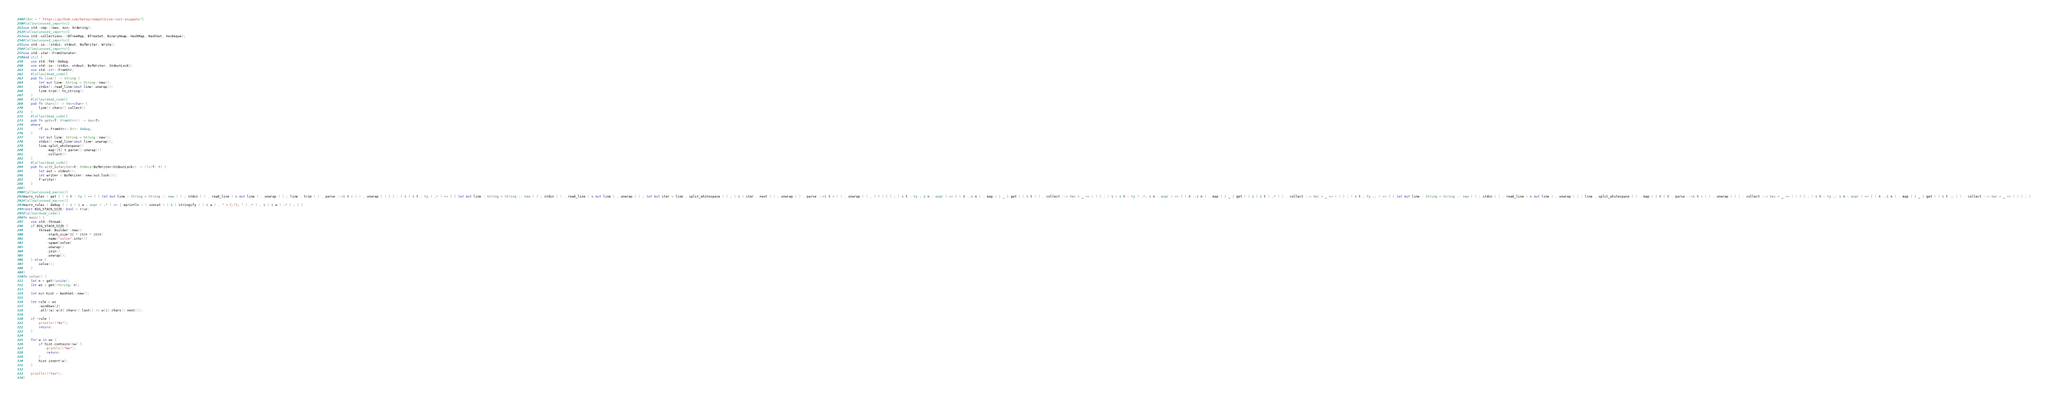Convert code to text. <code><loc_0><loc_0><loc_500><loc_500><_Rust_>#[doc = " https://github.com/hatoo/competitive-rust-snippets"]
#[allow(unused_imports)]
use std::cmp::{max, min, Ordering};
#[allow(unused_imports)]
use std::collections::{BTreeMap, BTreeSet, BinaryHeap, HashMap, HashSet, VecDeque};
#[allow(unused_imports)]
use std::io::{stdin, stdout, BufWriter, Write};
#[allow(unused_imports)]
use std::iter::FromIterator;
mod util {
    use std::fmt::Debug;
    use std::io::{stdin, stdout, BufWriter, StdoutLock};
    use std::str::FromStr;
    #[allow(dead_code)]
    pub fn line() -> String {
        let mut line: String = String::new();
        stdin().read_line(&mut line).unwrap();
        line.trim().to_string()
    }
    #[allow(dead_code)]
    pub fn chars() -> Vec<char> {
        line().chars().collect()
    }
    #[allow(dead_code)]
    pub fn gets<T: FromStr>() -> Vec<T>
    where
        <T as FromStr>::Err: Debug,
    {
        let mut line: String = String::new();
        stdin().read_line(&mut line).unwrap();
        line.split_whitespace()
            .map(|t| t.parse().unwrap())
            .collect()
    }
    #[allow(dead_code)]
    pub fn with_bufwriter<F: FnOnce(BufWriter<StdoutLock>) -> ()>(f: F) {
        let out = stdout();
        let writer = BufWriter::new(out.lock());
        f(writer)
    }
}
#[allow(unused_macros)]
macro_rules ! get { ( $ t : ty ) => { { let mut line : String = String :: new ( ) ; stdin ( ) . read_line ( & mut line ) . unwrap ( ) ; line . trim ( ) . parse ::<$ t > ( ) . unwrap ( ) } } ; ( $ ( $ t : ty ) ,* ) => { { let mut line : String = String :: new ( ) ; stdin ( ) . read_line ( & mut line ) . unwrap ( ) ; let mut iter = line . split_whitespace ( ) ; ( $ ( iter . next ( ) . unwrap ( ) . parse ::<$ t > ( ) . unwrap ( ) , ) * ) } } ; ( $ t : ty ; $ n : expr ) => { ( 0 ..$ n ) . map ( | _ | get ! ( $ t ) ) . collect ::< Vec < _ >> ( ) } ; ( $ ( $ t : ty ) ,*; $ n : expr ) => { ( 0 ..$ n ) . map ( | _ | get ! ( $ ( $ t ) ,* ) ) . collect ::< Vec < _ >> ( ) } ; ( $ t : ty ;; ) => { { let mut line : String = String :: new ( ) ; stdin ( ) . read_line ( & mut line ) . unwrap ( ) ; line . split_whitespace ( ) . map ( | t | t . parse ::<$ t > ( ) . unwrap ( ) ) . collect ::< Vec < _ >> ( ) } } ; ( $ t : ty ;; $ n : expr ) => { ( 0 ..$ n ) . map ( | _ | get ! ( $ t ;; ) ) . collect ::< Vec < _ >> ( ) } ; }
#[allow(unused_macros)]
macro_rules ! debug { ( $ ( $ a : expr ) ,* ) => { eprintln ! ( concat ! ( $ ( stringify ! ( $ a ) , " = {:?}, " ) ,* ) , $ ( $ a ) ,* ) ; } }
const BIG_STACK_SIZE: bool = true;
#[allow(dead_code)]
fn main() {
    use std::thread;
    if BIG_STACK_SIZE {
        thread::Builder::new()
            .stack_size(32 * 1024 * 1024)
            .name("solve".into())
            .spawn(solve)
            .unwrap()
            .join()
            .unwrap();
    } else {
        solve();
    }
}
fn solve() {
    let n = get!(usize);
    let ws = get!(String; n);

    let mut hist = HashSet::new();

    let rule = ws
        .windows(2)
        .all(|w| w[0].chars().last() == w[1].chars().next());

    if !rule {
        println!("No");
        return;
    }

    for w in ws {
        if hist.contains(&w) {
            println!("No");
            return;
        }
        hist.insert(w);
    }

    println!("Yes");
}
</code> 